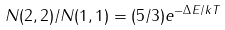<formula> <loc_0><loc_0><loc_500><loc_500>N ( 2 , 2 ) / N ( 1 , 1 ) = ( 5 / 3 ) e ^ { - \Delta E / k T }</formula> 